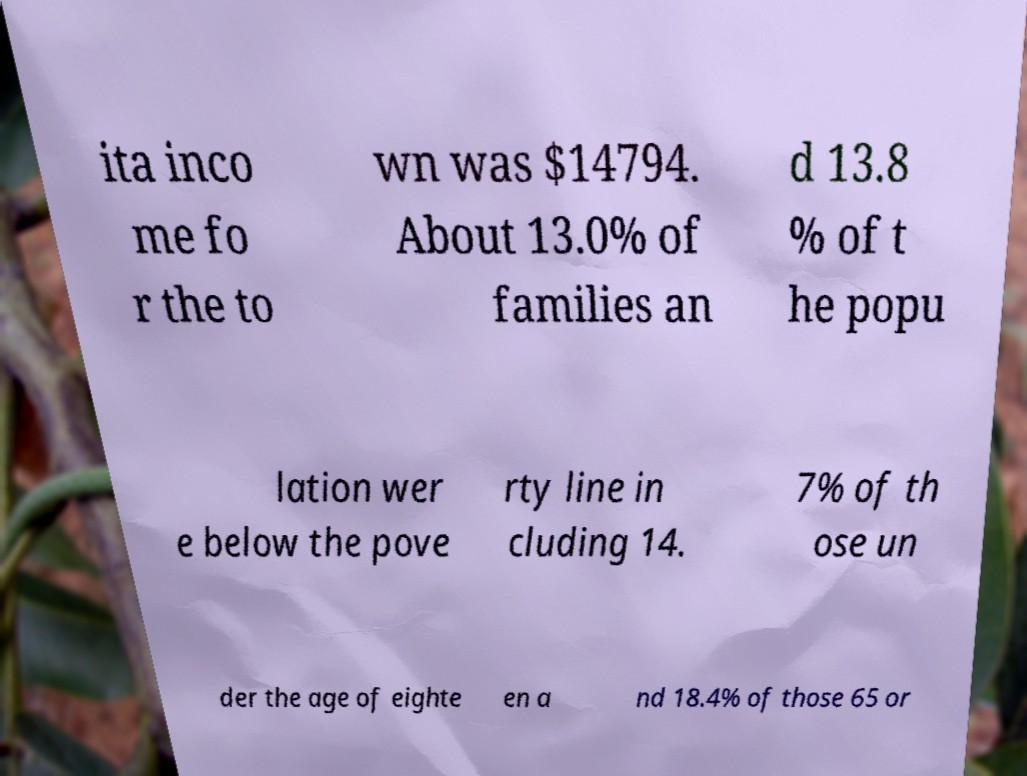There's text embedded in this image that I need extracted. Can you transcribe it verbatim? ita inco me fo r the to wn was $14794. About 13.0% of families an d 13.8 % of t he popu lation wer e below the pove rty line in cluding 14. 7% of th ose un der the age of eighte en a nd 18.4% of those 65 or 